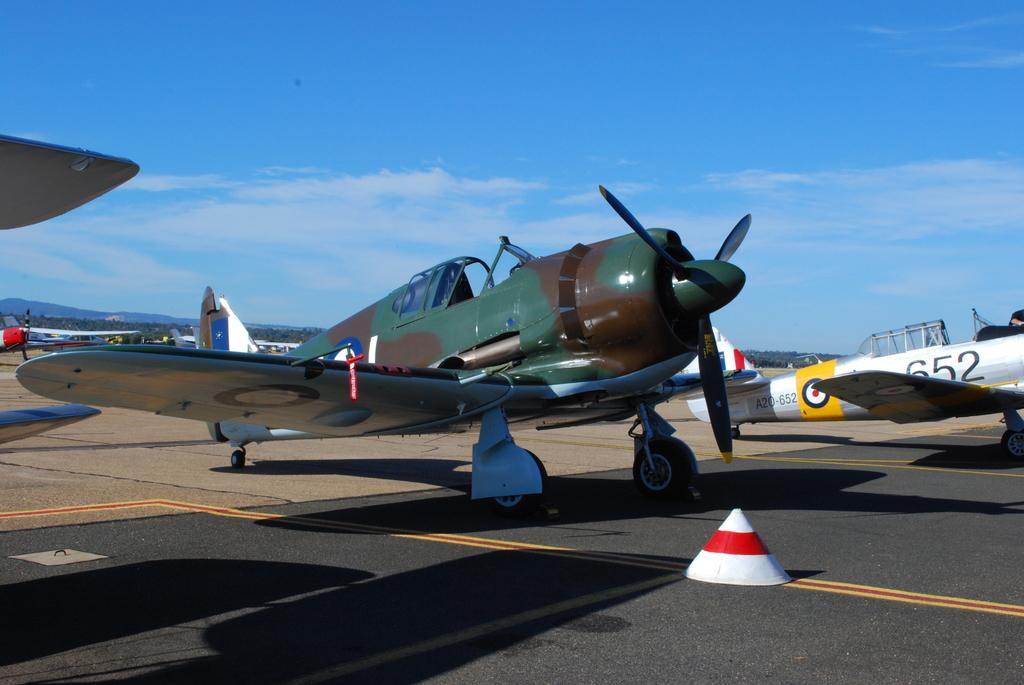What is the main subject of the image? The main subject of the image is aircrafts. What can be seen in the background of the image? There are trees, mountains, and the sky visible in the background of the image. What is the condition of the sky in the image? The sky is visible in the image, and there are clouds present. What is located at the bottom of the image? There is a road and an object at the bottom of the image. Can you see the giants walking on the trail in the image? There are no giants or trails present in the image. 